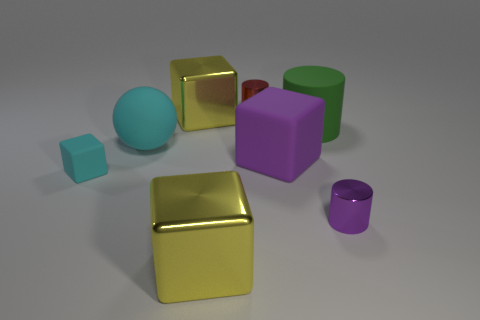Subtract 1 blocks. How many blocks are left? 3 Add 1 red metal things. How many objects exist? 9 Subtract all cylinders. How many objects are left? 5 Subtract 1 cyan blocks. How many objects are left? 7 Subtract all large rubber things. Subtract all large cylinders. How many objects are left? 4 Add 4 small purple objects. How many small purple objects are left? 5 Add 1 small purple shiny things. How many small purple shiny things exist? 2 